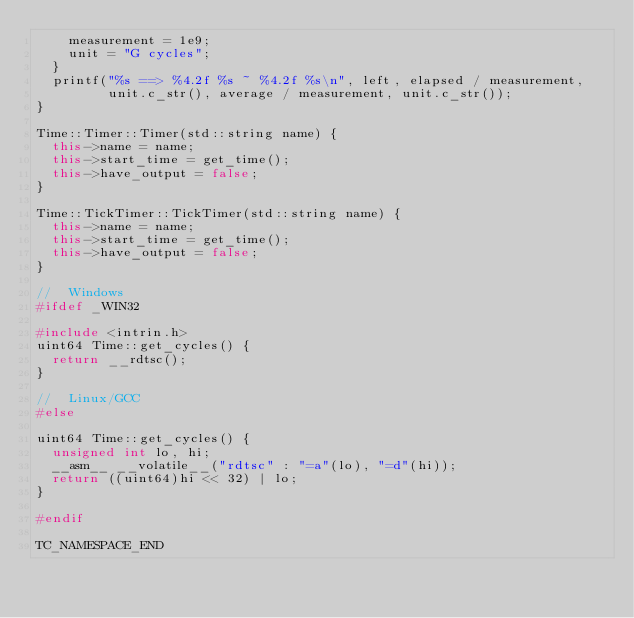<code> <loc_0><loc_0><loc_500><loc_500><_C++_>    measurement = 1e9;
    unit = "G cycles";
  }
  printf("%s ==> %4.2f %s ~ %4.2f %s\n", left, elapsed / measurement,
         unit.c_str(), average / measurement, unit.c_str());
}

Time::Timer::Timer(std::string name) {
  this->name = name;
  this->start_time = get_time();
  this->have_output = false;
}

Time::TickTimer::TickTimer(std::string name) {
  this->name = name;
  this->start_time = get_time();
  this->have_output = false;
}

//  Windows
#ifdef _WIN32

#include <intrin.h>
uint64 Time::get_cycles() {
  return __rdtsc();
}

//  Linux/GCC
#else

uint64 Time::get_cycles() {
  unsigned int lo, hi;
  __asm__ __volatile__("rdtsc" : "=a"(lo), "=d"(hi));
  return ((uint64)hi << 32) | lo;
}

#endif

TC_NAMESPACE_END
</code> 